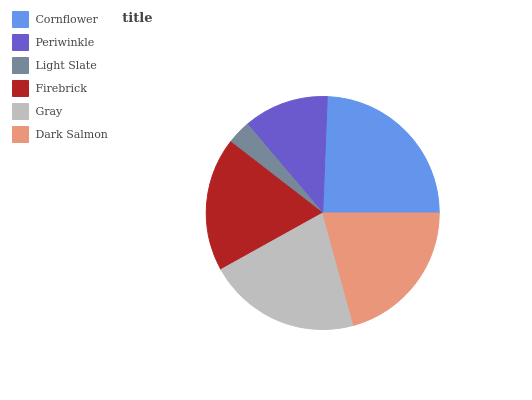Is Light Slate the minimum?
Answer yes or no. Yes. Is Cornflower the maximum?
Answer yes or no. Yes. Is Periwinkle the minimum?
Answer yes or no. No. Is Periwinkle the maximum?
Answer yes or no. No. Is Cornflower greater than Periwinkle?
Answer yes or no. Yes. Is Periwinkle less than Cornflower?
Answer yes or no. Yes. Is Periwinkle greater than Cornflower?
Answer yes or no. No. Is Cornflower less than Periwinkle?
Answer yes or no. No. Is Dark Salmon the high median?
Answer yes or no. Yes. Is Firebrick the low median?
Answer yes or no. Yes. Is Firebrick the high median?
Answer yes or no. No. Is Light Slate the low median?
Answer yes or no. No. 